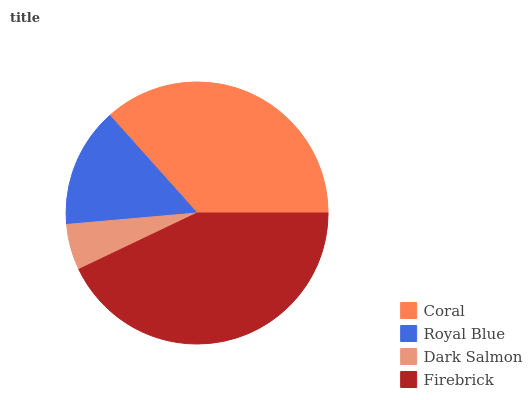Is Dark Salmon the minimum?
Answer yes or no. Yes. Is Firebrick the maximum?
Answer yes or no. Yes. Is Royal Blue the minimum?
Answer yes or no. No. Is Royal Blue the maximum?
Answer yes or no. No. Is Coral greater than Royal Blue?
Answer yes or no. Yes. Is Royal Blue less than Coral?
Answer yes or no. Yes. Is Royal Blue greater than Coral?
Answer yes or no. No. Is Coral less than Royal Blue?
Answer yes or no. No. Is Coral the high median?
Answer yes or no. Yes. Is Royal Blue the low median?
Answer yes or no. Yes. Is Dark Salmon the high median?
Answer yes or no. No. Is Dark Salmon the low median?
Answer yes or no. No. 